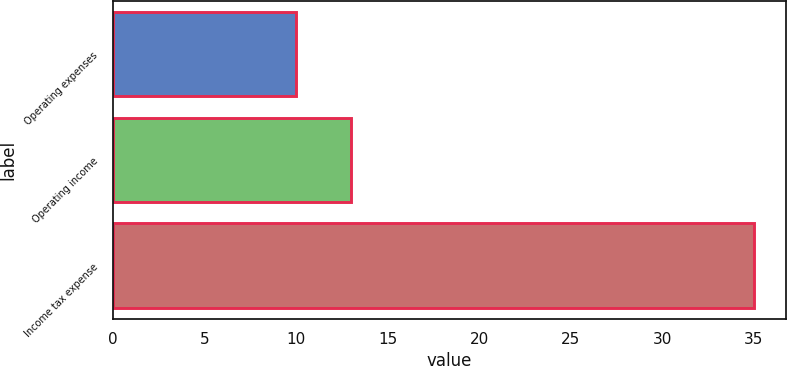Convert chart. <chart><loc_0><loc_0><loc_500><loc_500><bar_chart><fcel>Operating expenses<fcel>Operating income<fcel>Income tax expense<nl><fcel>10<fcel>13<fcel>35<nl></chart> 